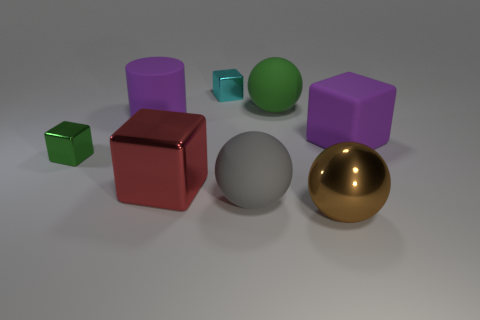There is a rubber cube that is the same color as the large rubber cylinder; what is its size?
Provide a succinct answer. Large. What number of other things are there of the same size as the shiny sphere?
Offer a terse response. 5. Does the metal ball have the same color as the tiny shiny object on the left side of the big metallic block?
Your answer should be compact. No. Is the number of green metallic objects to the right of the big gray matte ball less than the number of big purple blocks right of the purple block?
Provide a succinct answer. No. The big object that is both behind the gray sphere and in front of the tiny green shiny object is what color?
Your answer should be very brief. Red. There is a gray thing; is it the same size as the purple rubber object to the left of the brown shiny ball?
Offer a very short reply. Yes. What is the shape of the matte object to the right of the green matte ball?
Keep it short and to the point. Cube. Is there anything else that is the same material as the purple cylinder?
Offer a very short reply. Yes. Is the number of green things to the right of the gray matte sphere greater than the number of purple objects?
Provide a succinct answer. No. What number of blocks are left of the large rubber ball that is in front of the large block that is to the right of the big green sphere?
Make the answer very short. 3. 